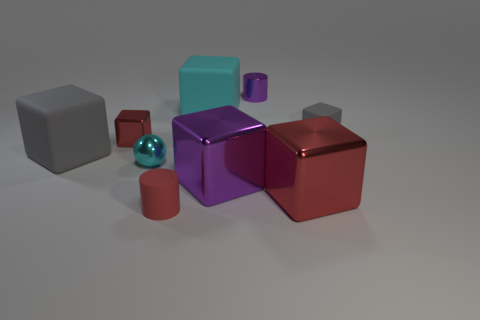Subtract 3 blocks. How many blocks are left? 3 Subtract all blue cylinders. How many red blocks are left? 2 Subtract all gray cubes. How many cubes are left? 4 Subtract all tiny metal cubes. How many cubes are left? 5 Subtract all brown blocks. Subtract all purple cylinders. How many blocks are left? 6 Add 8 red cubes. How many red cubes are left? 10 Add 4 large purple metallic cubes. How many large purple metallic cubes exist? 5 Subtract 0 blue balls. How many objects are left? 9 Subtract all blocks. How many objects are left? 3 Subtract all yellow metal objects. Subtract all red metallic cubes. How many objects are left? 7 